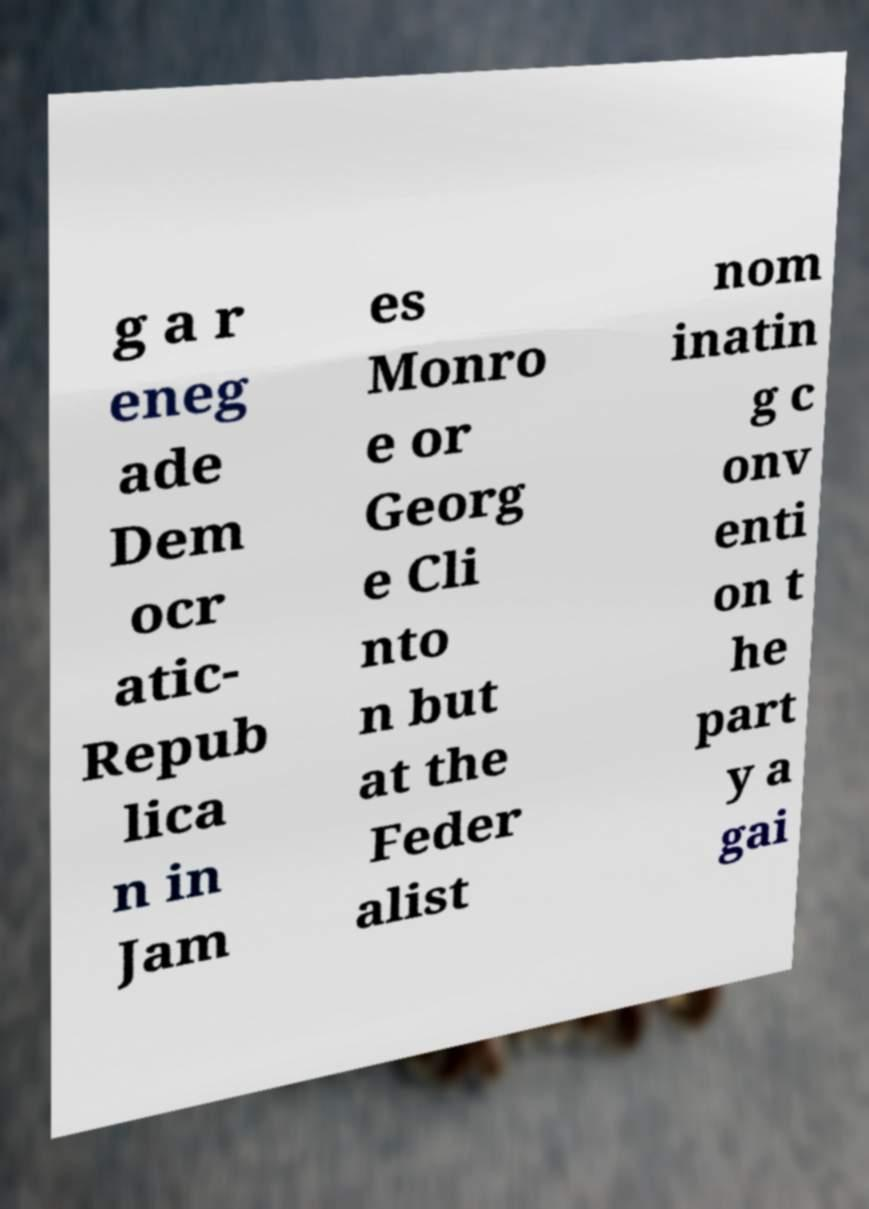Could you extract and type out the text from this image? g a r eneg ade Dem ocr atic- Repub lica n in Jam es Monro e or Georg e Cli nto n but at the Feder alist nom inatin g c onv enti on t he part y a gai 